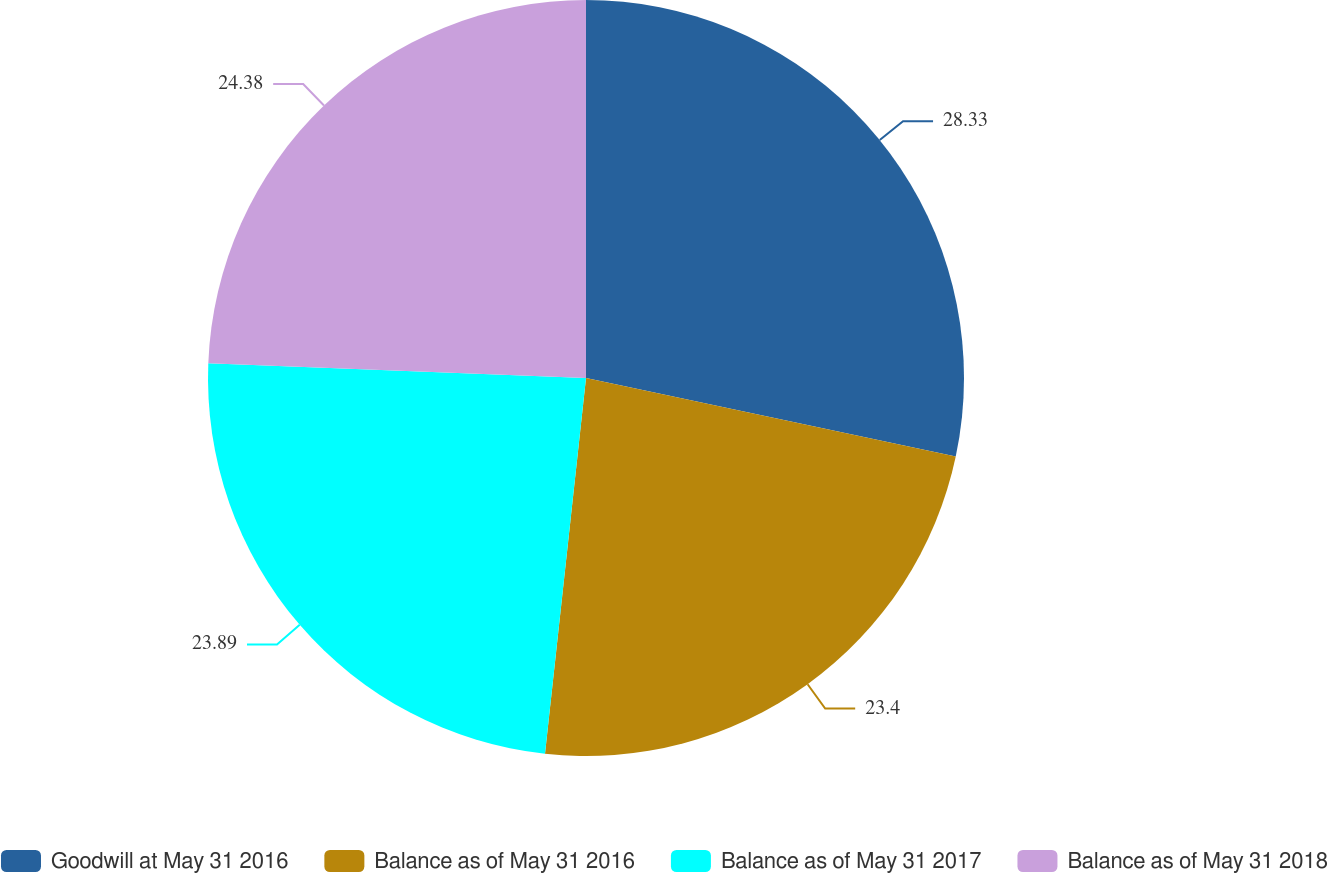Convert chart. <chart><loc_0><loc_0><loc_500><loc_500><pie_chart><fcel>Goodwill at May 31 2016<fcel>Balance as of May 31 2016<fcel>Balance as of May 31 2017<fcel>Balance as of May 31 2018<nl><fcel>28.33%<fcel>23.4%<fcel>23.89%<fcel>24.38%<nl></chart> 